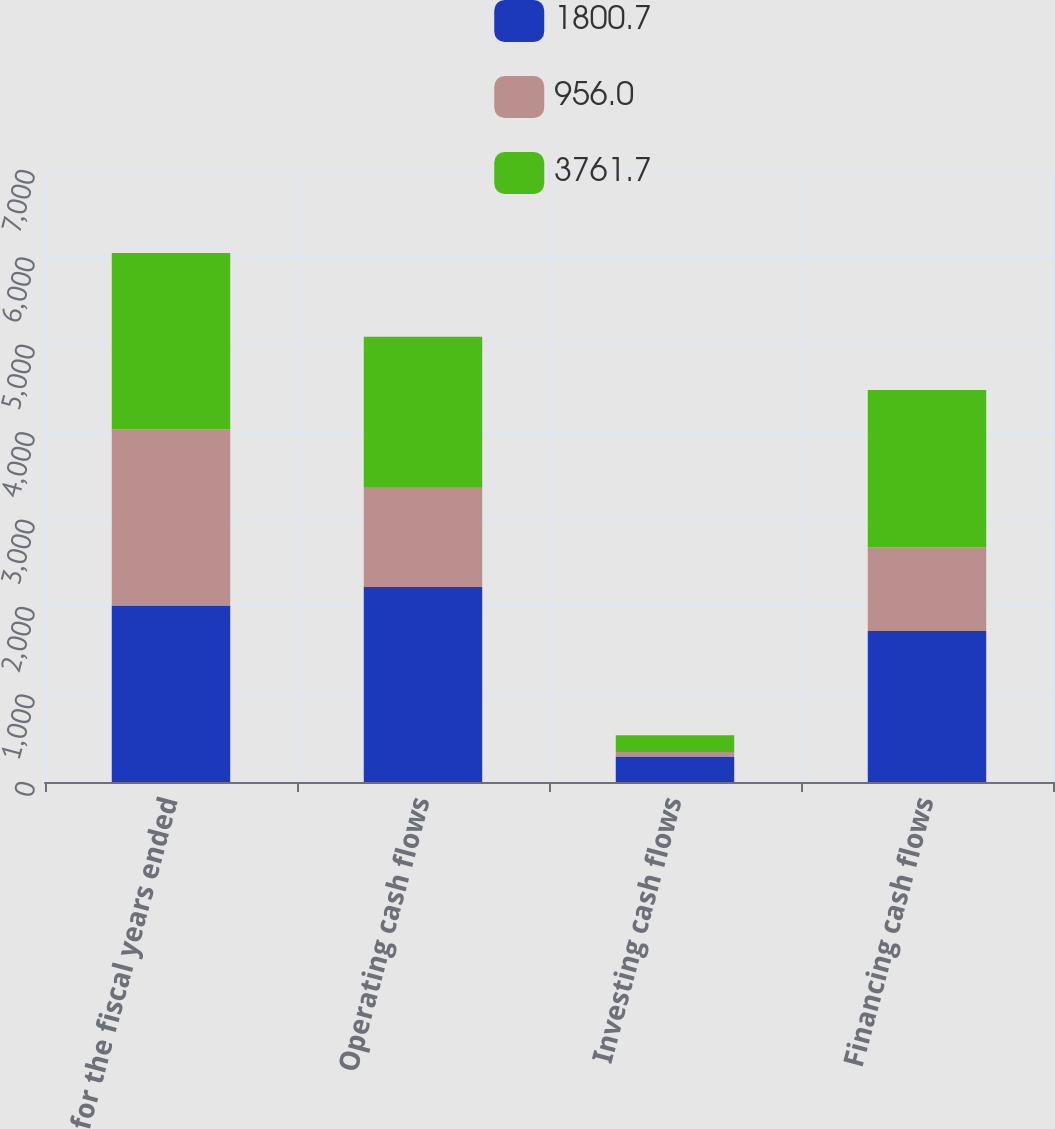Convert chart. <chart><loc_0><loc_0><loc_500><loc_500><stacked_bar_chart><ecel><fcel>for the fiscal years ended<fcel>Operating cash flows<fcel>Investing cash flows<fcel>Financing cash flows<nl><fcel>1800.7<fcel>2018<fcel>2229.7<fcel>290.4<fcel>1727.7<nl><fcel>956<fcel>2017<fcel>1135.4<fcel>52<fcel>956<nl><fcel>3761.7<fcel>2016<fcel>1727.7<fcel>192.2<fcel>1800.7<nl></chart> 